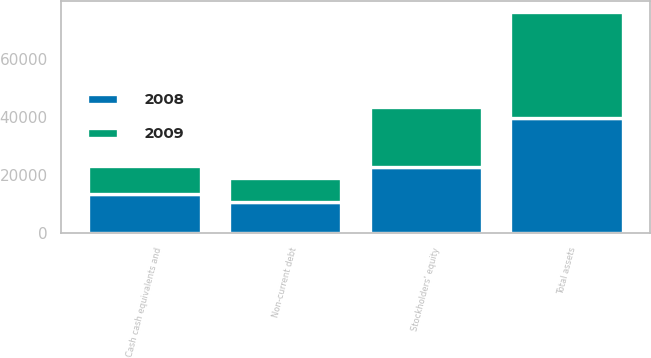Convert chart to OTSL. <chart><loc_0><loc_0><loc_500><loc_500><stacked_bar_chart><ecel><fcel>Cash cash equivalents and<fcel>Total assets<fcel>Non-current debt<fcel>Stockholders' equity<nl><fcel>2008<fcel>13442<fcel>39629<fcel>10601<fcel>22667<nl><fcel>2009<fcel>9552<fcel>36427<fcel>8352<fcel>20885<nl></chart> 